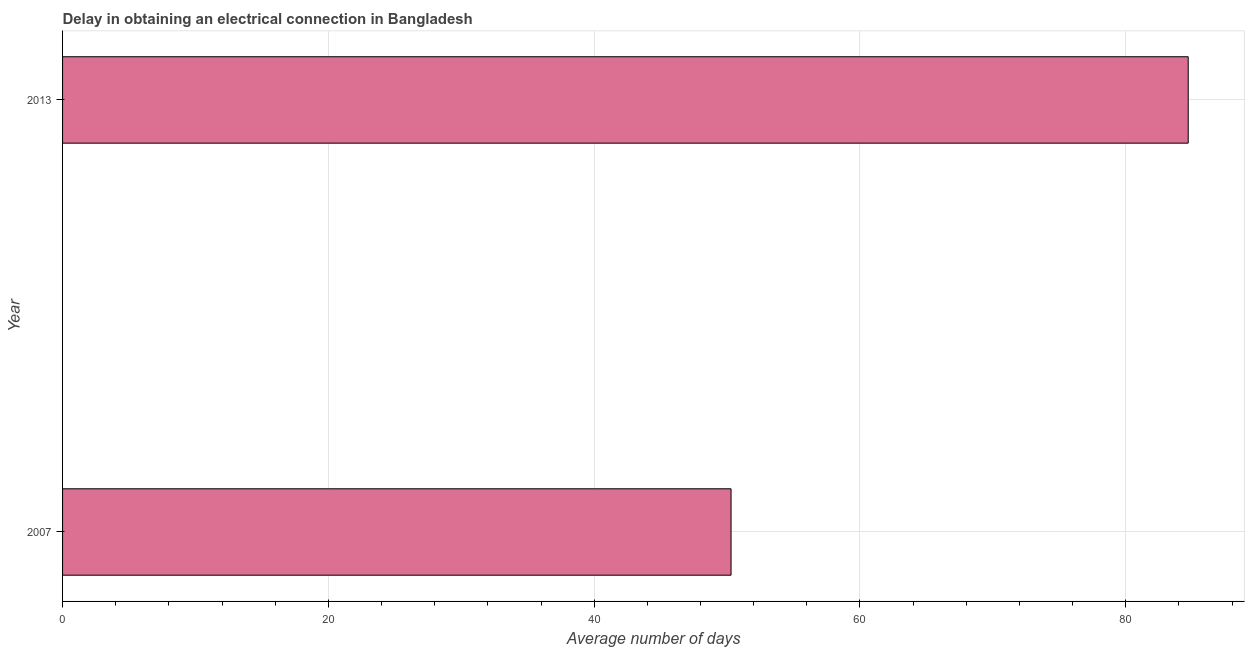Does the graph contain any zero values?
Provide a succinct answer. No. What is the title of the graph?
Provide a succinct answer. Delay in obtaining an electrical connection in Bangladesh. What is the label or title of the X-axis?
Offer a terse response. Average number of days. What is the label or title of the Y-axis?
Give a very brief answer. Year. What is the dalay in electrical connection in 2007?
Your response must be concise. 50.3. Across all years, what is the maximum dalay in electrical connection?
Your answer should be very brief. 84.7. Across all years, what is the minimum dalay in electrical connection?
Offer a terse response. 50.3. What is the sum of the dalay in electrical connection?
Your answer should be very brief. 135. What is the difference between the dalay in electrical connection in 2007 and 2013?
Your response must be concise. -34.4. What is the average dalay in electrical connection per year?
Provide a succinct answer. 67.5. What is the median dalay in electrical connection?
Give a very brief answer. 67.5. What is the ratio of the dalay in electrical connection in 2007 to that in 2013?
Offer a terse response. 0.59. Is the dalay in electrical connection in 2007 less than that in 2013?
Give a very brief answer. Yes. In how many years, is the dalay in electrical connection greater than the average dalay in electrical connection taken over all years?
Ensure brevity in your answer.  1. How many bars are there?
Keep it short and to the point. 2. Are all the bars in the graph horizontal?
Offer a very short reply. Yes. How many years are there in the graph?
Your answer should be compact. 2. Are the values on the major ticks of X-axis written in scientific E-notation?
Provide a succinct answer. No. What is the Average number of days of 2007?
Your response must be concise. 50.3. What is the Average number of days in 2013?
Provide a short and direct response. 84.7. What is the difference between the Average number of days in 2007 and 2013?
Provide a succinct answer. -34.4. What is the ratio of the Average number of days in 2007 to that in 2013?
Provide a succinct answer. 0.59. 